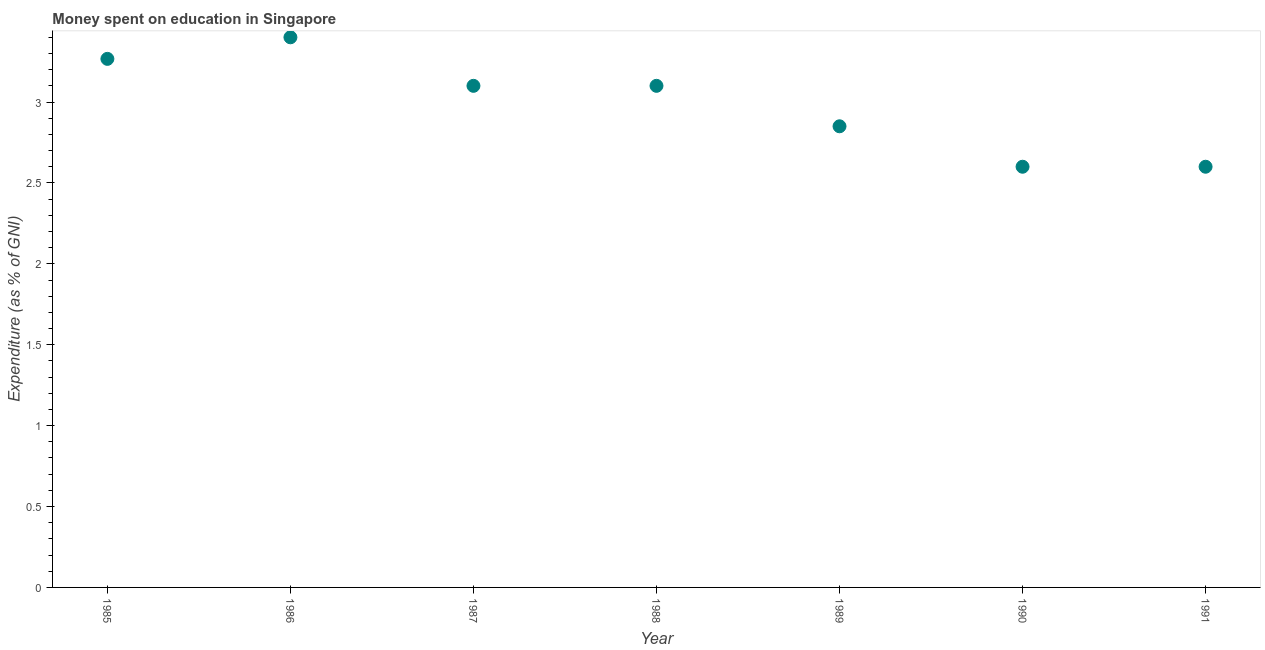What is the expenditure on education in 1989?
Your answer should be compact. 2.85. Across all years, what is the minimum expenditure on education?
Provide a succinct answer. 2.6. In which year was the expenditure on education maximum?
Provide a succinct answer. 1986. In which year was the expenditure on education minimum?
Your answer should be very brief. 1990. What is the sum of the expenditure on education?
Your answer should be very brief. 20.92. What is the difference between the expenditure on education in 1986 and 1990?
Offer a very short reply. 0.8. What is the average expenditure on education per year?
Provide a succinct answer. 2.99. Do a majority of the years between 1991 and 1990 (inclusive) have expenditure on education greater than 2.5 %?
Give a very brief answer. No. What is the ratio of the expenditure on education in 1985 to that in 1991?
Keep it short and to the point. 1.26. Is the expenditure on education in 1985 less than that in 1986?
Offer a terse response. Yes. Is the difference between the expenditure on education in 1986 and 1991 greater than the difference between any two years?
Provide a short and direct response. Yes. What is the difference between the highest and the second highest expenditure on education?
Make the answer very short. 0.13. Is the sum of the expenditure on education in 1987 and 1990 greater than the maximum expenditure on education across all years?
Offer a terse response. Yes. What is the difference between the highest and the lowest expenditure on education?
Ensure brevity in your answer.  0.8. How many dotlines are there?
Your answer should be very brief. 1. What is the difference between two consecutive major ticks on the Y-axis?
Your answer should be very brief. 0.5. Are the values on the major ticks of Y-axis written in scientific E-notation?
Your answer should be compact. No. Does the graph contain grids?
Provide a short and direct response. No. What is the title of the graph?
Offer a very short reply. Money spent on education in Singapore. What is the label or title of the Y-axis?
Offer a very short reply. Expenditure (as % of GNI). What is the Expenditure (as % of GNI) in 1985?
Offer a terse response. 3.27. What is the Expenditure (as % of GNI) in 1989?
Offer a terse response. 2.85. What is the Expenditure (as % of GNI) in 1991?
Ensure brevity in your answer.  2.6. What is the difference between the Expenditure (as % of GNI) in 1985 and 1986?
Ensure brevity in your answer.  -0.13. What is the difference between the Expenditure (as % of GNI) in 1985 and 1987?
Ensure brevity in your answer.  0.17. What is the difference between the Expenditure (as % of GNI) in 1985 and 1988?
Your response must be concise. 0.17. What is the difference between the Expenditure (as % of GNI) in 1985 and 1989?
Offer a very short reply. 0.42. What is the difference between the Expenditure (as % of GNI) in 1985 and 1990?
Ensure brevity in your answer.  0.67. What is the difference between the Expenditure (as % of GNI) in 1985 and 1991?
Ensure brevity in your answer.  0.67. What is the difference between the Expenditure (as % of GNI) in 1986 and 1987?
Provide a succinct answer. 0.3. What is the difference between the Expenditure (as % of GNI) in 1986 and 1988?
Keep it short and to the point. 0.3. What is the difference between the Expenditure (as % of GNI) in 1986 and 1989?
Your answer should be compact. 0.55. What is the difference between the Expenditure (as % of GNI) in 1986 and 1991?
Provide a short and direct response. 0.8. What is the difference between the Expenditure (as % of GNI) in 1987 and 1989?
Offer a terse response. 0.25. What is the difference between the Expenditure (as % of GNI) in 1987 and 1991?
Your response must be concise. 0.5. What is the difference between the Expenditure (as % of GNI) in 1988 and 1990?
Make the answer very short. 0.5. What is the difference between the Expenditure (as % of GNI) in 1988 and 1991?
Provide a succinct answer. 0.5. What is the difference between the Expenditure (as % of GNI) in 1990 and 1991?
Your answer should be very brief. 0. What is the ratio of the Expenditure (as % of GNI) in 1985 to that in 1987?
Give a very brief answer. 1.05. What is the ratio of the Expenditure (as % of GNI) in 1985 to that in 1988?
Your answer should be very brief. 1.05. What is the ratio of the Expenditure (as % of GNI) in 1985 to that in 1989?
Your response must be concise. 1.15. What is the ratio of the Expenditure (as % of GNI) in 1985 to that in 1990?
Your answer should be very brief. 1.26. What is the ratio of the Expenditure (as % of GNI) in 1985 to that in 1991?
Ensure brevity in your answer.  1.26. What is the ratio of the Expenditure (as % of GNI) in 1986 to that in 1987?
Make the answer very short. 1.1. What is the ratio of the Expenditure (as % of GNI) in 1986 to that in 1988?
Provide a succinct answer. 1.1. What is the ratio of the Expenditure (as % of GNI) in 1986 to that in 1989?
Ensure brevity in your answer.  1.19. What is the ratio of the Expenditure (as % of GNI) in 1986 to that in 1990?
Provide a short and direct response. 1.31. What is the ratio of the Expenditure (as % of GNI) in 1986 to that in 1991?
Offer a very short reply. 1.31. What is the ratio of the Expenditure (as % of GNI) in 1987 to that in 1989?
Ensure brevity in your answer.  1.09. What is the ratio of the Expenditure (as % of GNI) in 1987 to that in 1990?
Ensure brevity in your answer.  1.19. What is the ratio of the Expenditure (as % of GNI) in 1987 to that in 1991?
Ensure brevity in your answer.  1.19. What is the ratio of the Expenditure (as % of GNI) in 1988 to that in 1989?
Your answer should be compact. 1.09. What is the ratio of the Expenditure (as % of GNI) in 1988 to that in 1990?
Your answer should be very brief. 1.19. What is the ratio of the Expenditure (as % of GNI) in 1988 to that in 1991?
Give a very brief answer. 1.19. What is the ratio of the Expenditure (as % of GNI) in 1989 to that in 1990?
Your answer should be compact. 1.1. What is the ratio of the Expenditure (as % of GNI) in 1989 to that in 1991?
Give a very brief answer. 1.1. 